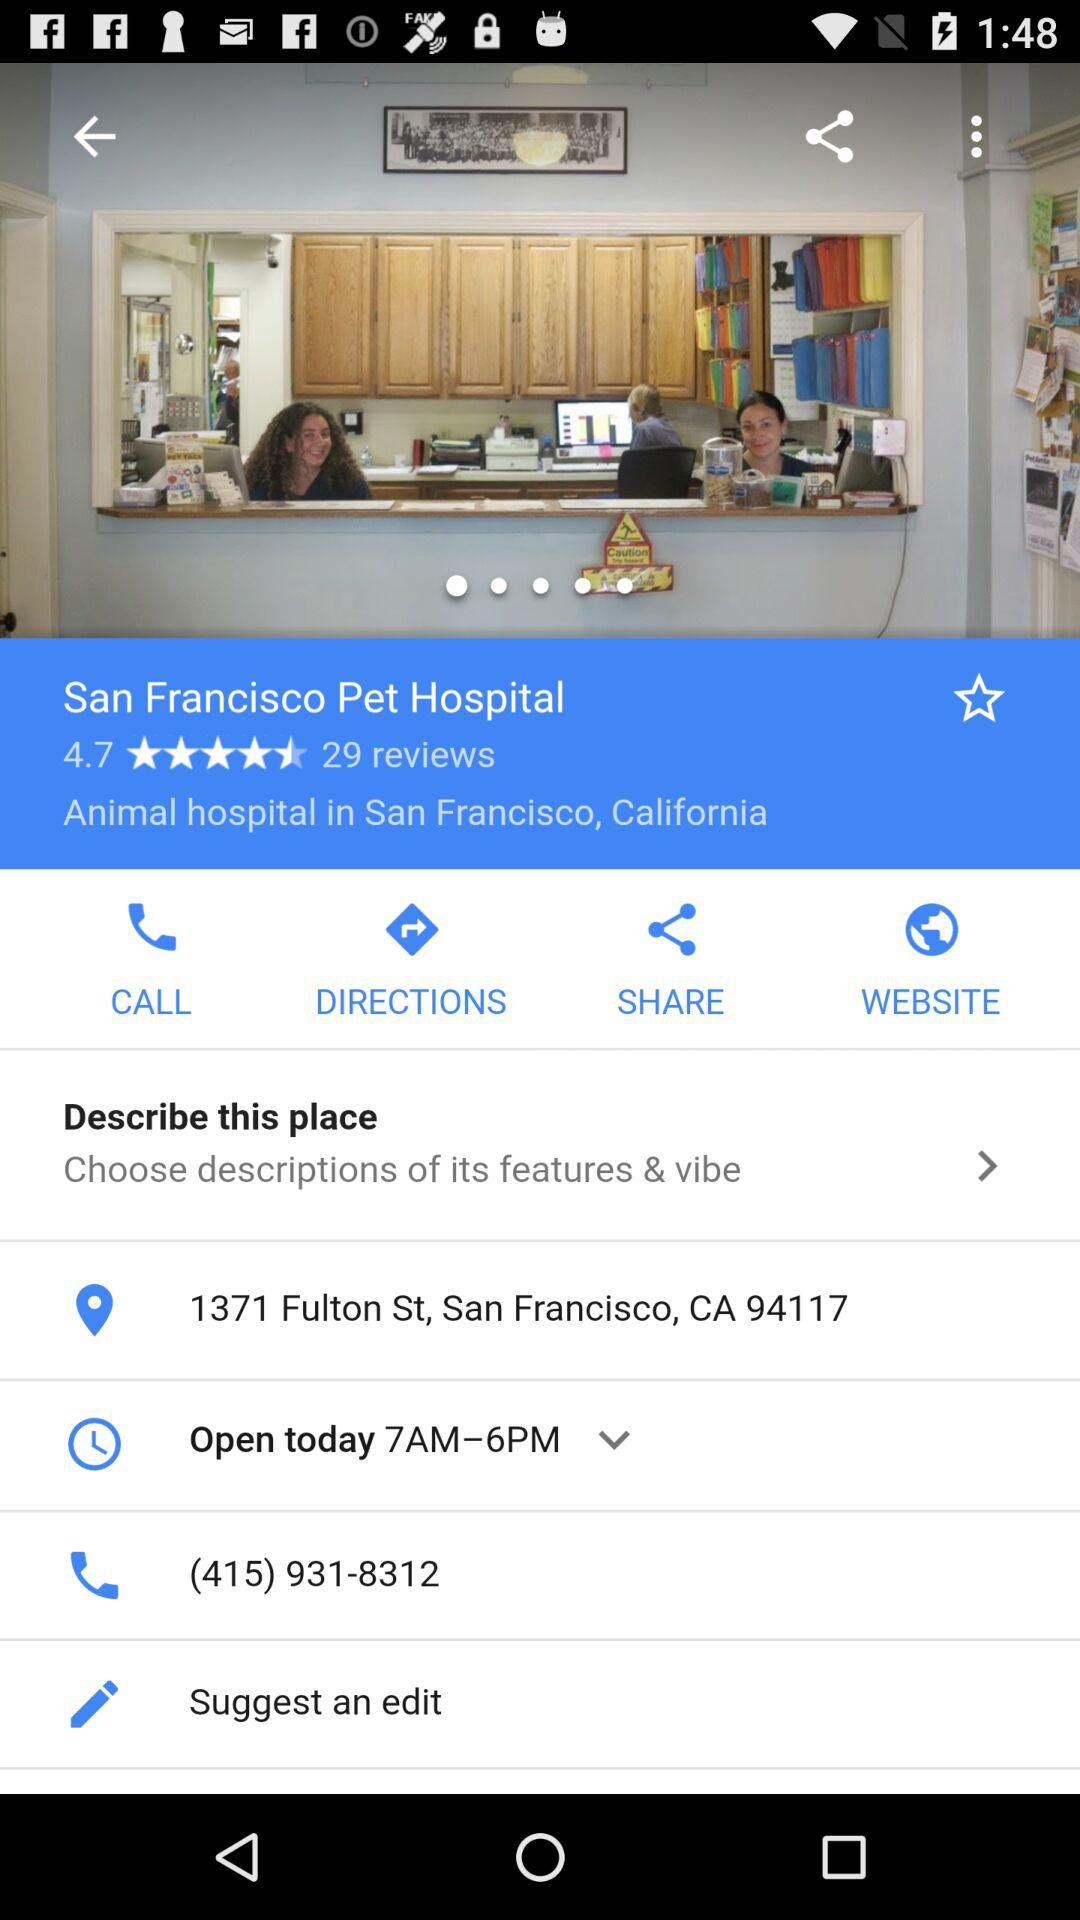What is the opening time for today? The opening time is from 7 a.m. to 6 p.m. 